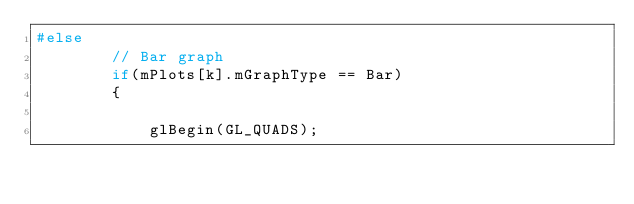<code> <loc_0><loc_0><loc_500><loc_500><_C++_>#else
		// Bar graph
		if(mPlots[k].mGraphType == Bar)
		{

			glBegin(GL_QUADS);
</code> 